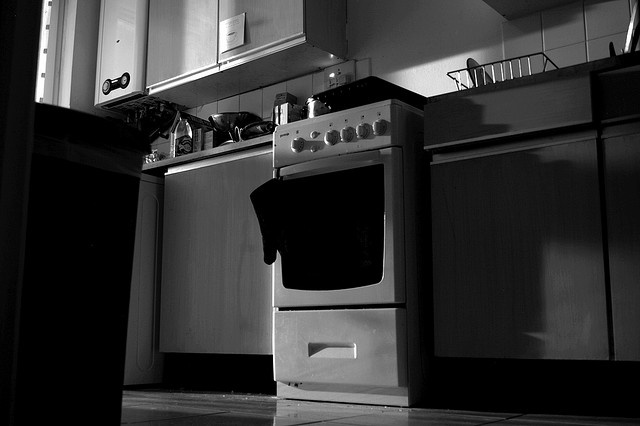Describe the objects in this image and their specific colors. I can see oven in black, darkgray, gray, and lightgray tones, bowl in black, gray, darkgray, and white tones, bottle in black, gray, lightgray, and darkgray tones, and knife in black tones in this image. 